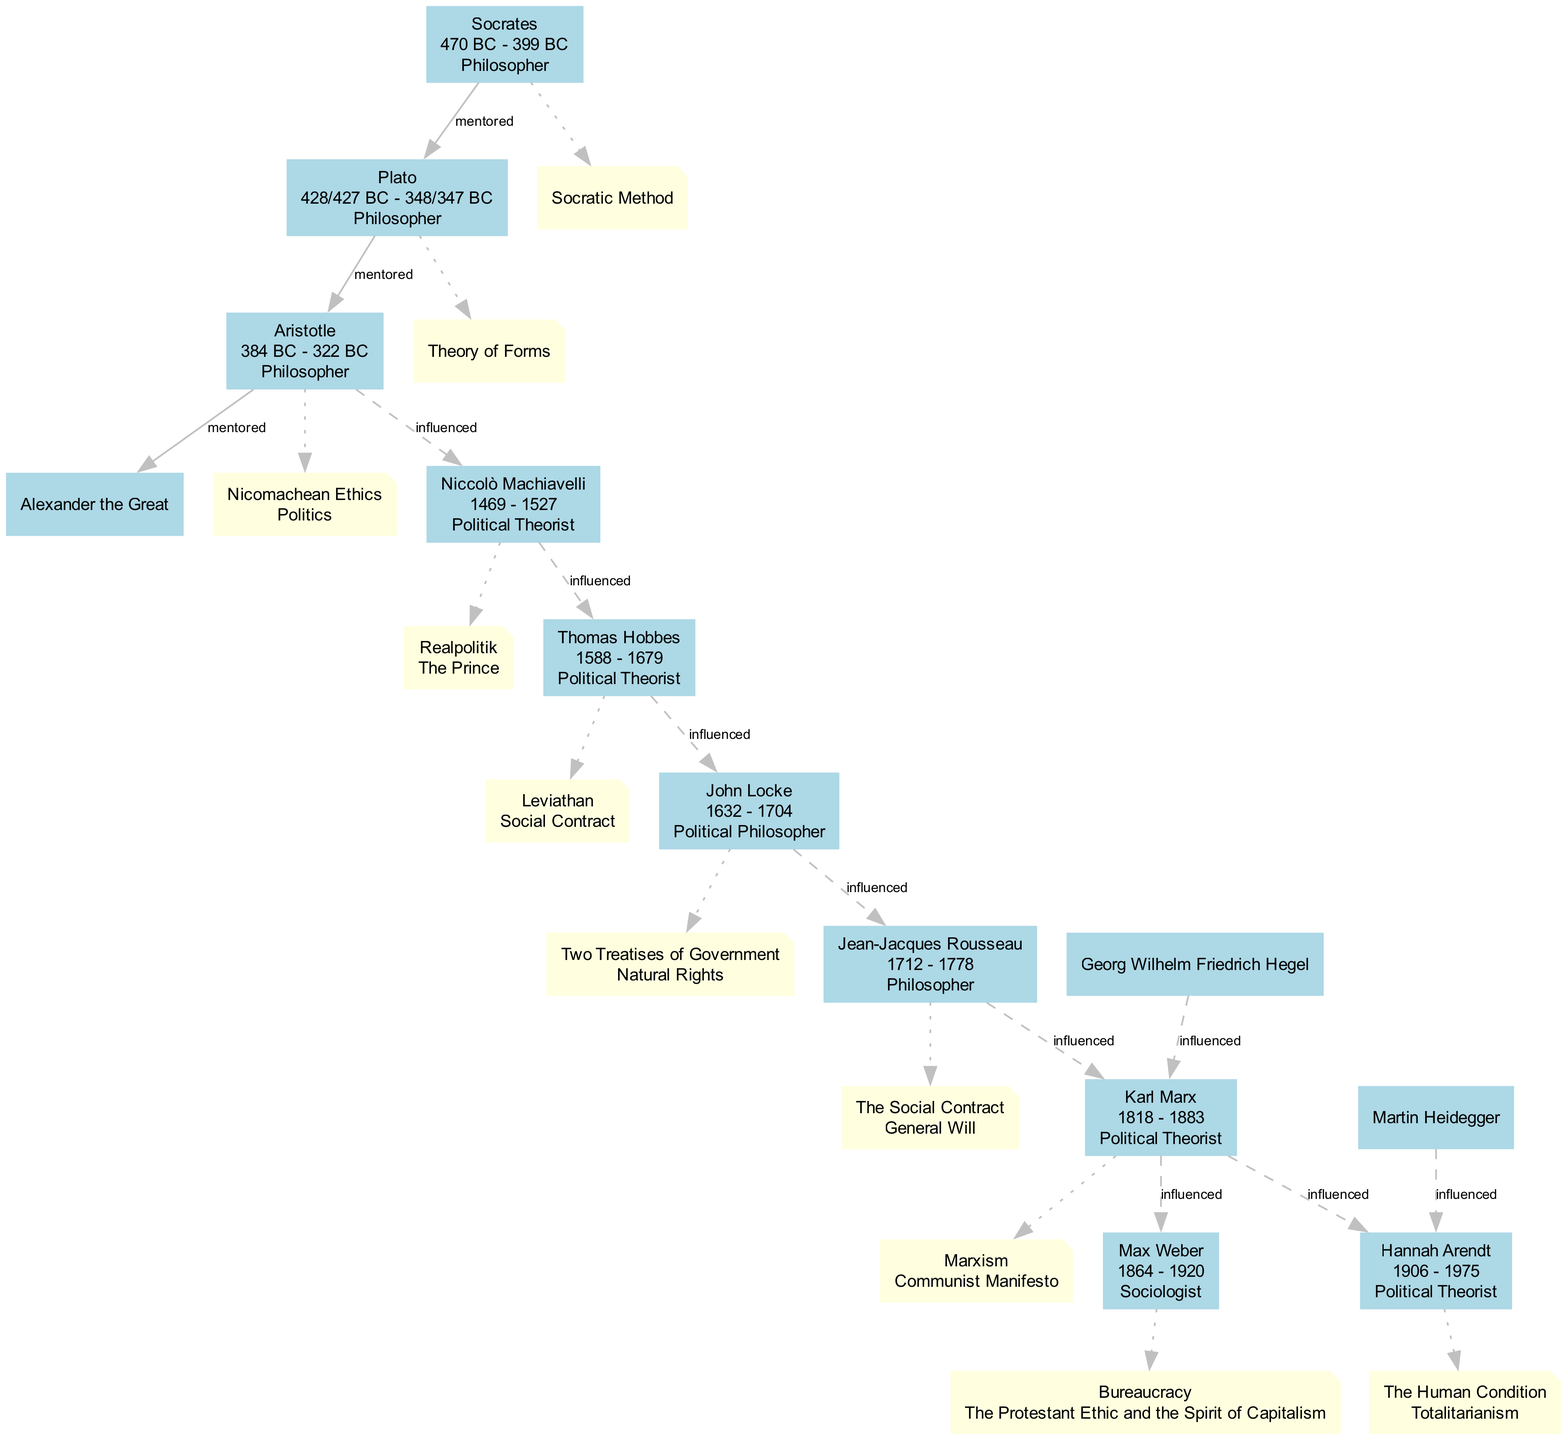What is the birthdate of John Locke? According to the diagram, John Locke's birth year is stated as 1632.
Answer: 1632 Who influenced Hannah Arendt? The diagram indicates that Hannah Arendt was influenced by Karl Marx and Martin Heidegger.
Answer: Karl Marx, Martin Heidegger How many political theorists are mentoring others in the diagram? By analyzing the connections, we see that Socrates, Plato, and Aristotle each have mentees, making a total of three political theorists mentoring others.
Answer: 3 Which philosopher was mentored by Socrates? Referring to the diagram, we find that Plato was mentored by Socrates.
Answer: Plato Who did Aristotle mentor? The diagram shows that Aristotle mentored Alexander the Great.
Answer: Alexander the Great What ideology is associated with Niccolò Machiavelli? The diagram lists "Realpolitik" and "The Prince" as ideologies associated with Niccolò Machiavelli.
Answer: Realpolitik, The Prince Which theorist's ideas influenced both Karl Marx and Max Weber? The connections indicate that Karl Marx was influenced by Jean-Jacques Rousseau, which also led to his influence on Max Weber.
Answer: Jean-Jacques Rousseau How many individuals are directly influenced by Thomas Hobbes? The diagram indicates that only John Locke is directly influenced by Thomas Hobbes.
Answer: 1 What is the role of Aristotle in the tree? According to the diagram, Aristotle is identified as a philosopher.
Answer: Philosopher 